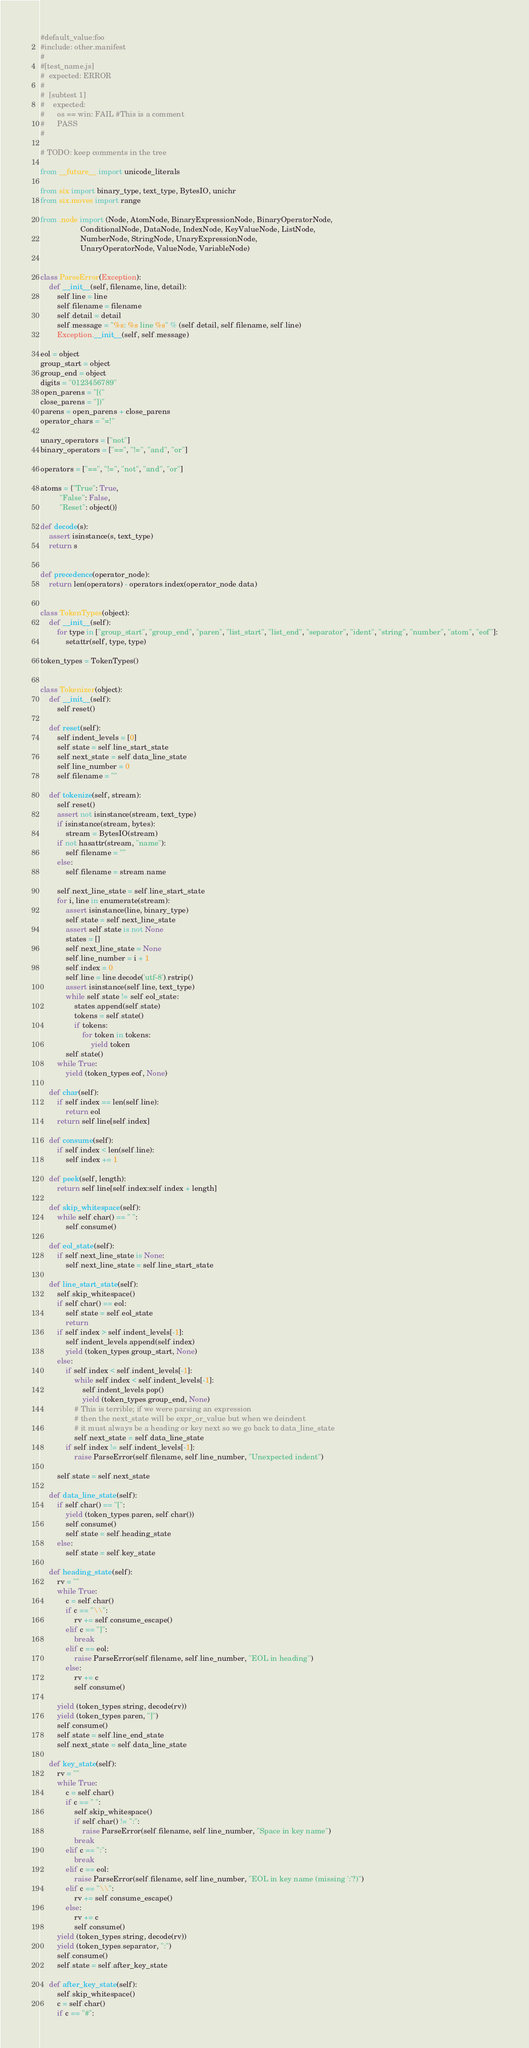Convert code to text. <code><loc_0><loc_0><loc_500><loc_500><_Python_>#default_value:foo
#include: other.manifest
#
#[test_name.js]
#  expected: ERROR
#
#  [subtest 1]
#    expected:
#      os == win: FAIL #This is a comment
#      PASS
#

# TODO: keep comments in the tree

from __future__ import unicode_literals

from six import binary_type, text_type, BytesIO, unichr
from six.moves import range

from .node import (Node, AtomNode, BinaryExpressionNode, BinaryOperatorNode,
                   ConditionalNode, DataNode, IndexNode, KeyValueNode, ListNode,
                   NumberNode, StringNode, UnaryExpressionNode,
                   UnaryOperatorNode, ValueNode, VariableNode)


class ParseError(Exception):
    def __init__(self, filename, line, detail):
        self.line = line
        self.filename = filename
        self.detail = detail
        self.message = "%s: %s line %s" % (self.detail, self.filename, self.line)
        Exception.__init__(self, self.message)

eol = object
group_start = object
group_end = object
digits = "0123456789"
open_parens = "[("
close_parens = "])"
parens = open_parens + close_parens
operator_chars = "=!"

unary_operators = ["not"]
binary_operators = ["==", "!=", "and", "or"]

operators = ["==", "!=", "not", "and", "or"]

atoms = {"True": True,
         "False": False,
         "Reset": object()}

def decode(s):
    assert isinstance(s, text_type)
    return s


def precedence(operator_node):
    return len(operators) - operators.index(operator_node.data)


class TokenTypes(object):
    def __init__(self):
        for type in ["group_start", "group_end", "paren", "list_start", "list_end", "separator", "ident", "string", "number", "atom", "eof"]:
            setattr(self, type, type)

token_types = TokenTypes()


class Tokenizer(object):
    def __init__(self):
        self.reset()

    def reset(self):
        self.indent_levels = [0]
        self.state = self.line_start_state
        self.next_state = self.data_line_state
        self.line_number = 0
        self.filename = ""

    def tokenize(self, stream):
        self.reset()
        assert not isinstance(stream, text_type)
        if isinstance(stream, bytes):
            stream = BytesIO(stream)
        if not hasattr(stream, "name"):
            self.filename = ""
        else:
            self.filename = stream.name

        self.next_line_state = self.line_start_state
        for i, line in enumerate(stream):
            assert isinstance(line, binary_type)
            self.state = self.next_line_state
            assert self.state is not None
            states = []
            self.next_line_state = None
            self.line_number = i + 1
            self.index = 0
            self.line = line.decode('utf-8').rstrip()
            assert isinstance(self.line, text_type)
            while self.state != self.eol_state:
                states.append(self.state)
                tokens = self.state()
                if tokens:
                    for token in tokens:
                        yield token
            self.state()
        while True:
            yield (token_types.eof, None)

    def char(self):
        if self.index == len(self.line):
            return eol
        return self.line[self.index]

    def consume(self):
        if self.index < len(self.line):
            self.index += 1

    def peek(self, length):
        return self.line[self.index:self.index + length]

    def skip_whitespace(self):
        while self.char() == " ":
            self.consume()

    def eol_state(self):
        if self.next_line_state is None:
            self.next_line_state = self.line_start_state

    def line_start_state(self):
        self.skip_whitespace()
        if self.char() == eol:
            self.state = self.eol_state
            return
        if self.index > self.indent_levels[-1]:
            self.indent_levels.append(self.index)
            yield (token_types.group_start, None)
        else:
            if self.index < self.indent_levels[-1]:
                while self.index < self.indent_levels[-1]:
                    self.indent_levels.pop()
                    yield (token_types.group_end, None)
                # This is terrible; if we were parsing an expression
                # then the next_state will be expr_or_value but when we deindent
                # it must always be a heading or key next so we go back to data_line_state
                self.next_state = self.data_line_state
            if self.index != self.indent_levels[-1]:
                raise ParseError(self.filename, self.line_number, "Unexpected indent")

        self.state = self.next_state

    def data_line_state(self):
        if self.char() == "[":
            yield (token_types.paren, self.char())
            self.consume()
            self.state = self.heading_state
        else:
            self.state = self.key_state

    def heading_state(self):
        rv = ""
        while True:
            c = self.char()
            if c == "\\":
                rv += self.consume_escape()
            elif c == "]":
                break
            elif c == eol:
                raise ParseError(self.filename, self.line_number, "EOL in heading")
            else:
                rv += c
                self.consume()

        yield (token_types.string, decode(rv))
        yield (token_types.paren, "]")
        self.consume()
        self.state = self.line_end_state
        self.next_state = self.data_line_state

    def key_state(self):
        rv = ""
        while True:
            c = self.char()
            if c == " ":
                self.skip_whitespace()
                if self.char() != ":":
                    raise ParseError(self.filename, self.line_number, "Space in key name")
                break
            elif c == ":":
                break
            elif c == eol:
                raise ParseError(self.filename, self.line_number, "EOL in key name (missing ':'?)")
            elif c == "\\":
                rv += self.consume_escape()
            else:
                rv += c
                self.consume()
        yield (token_types.string, decode(rv))
        yield (token_types.separator, ":")
        self.consume()
        self.state = self.after_key_state

    def after_key_state(self):
        self.skip_whitespace()
        c = self.char()
        if c == "#":</code> 